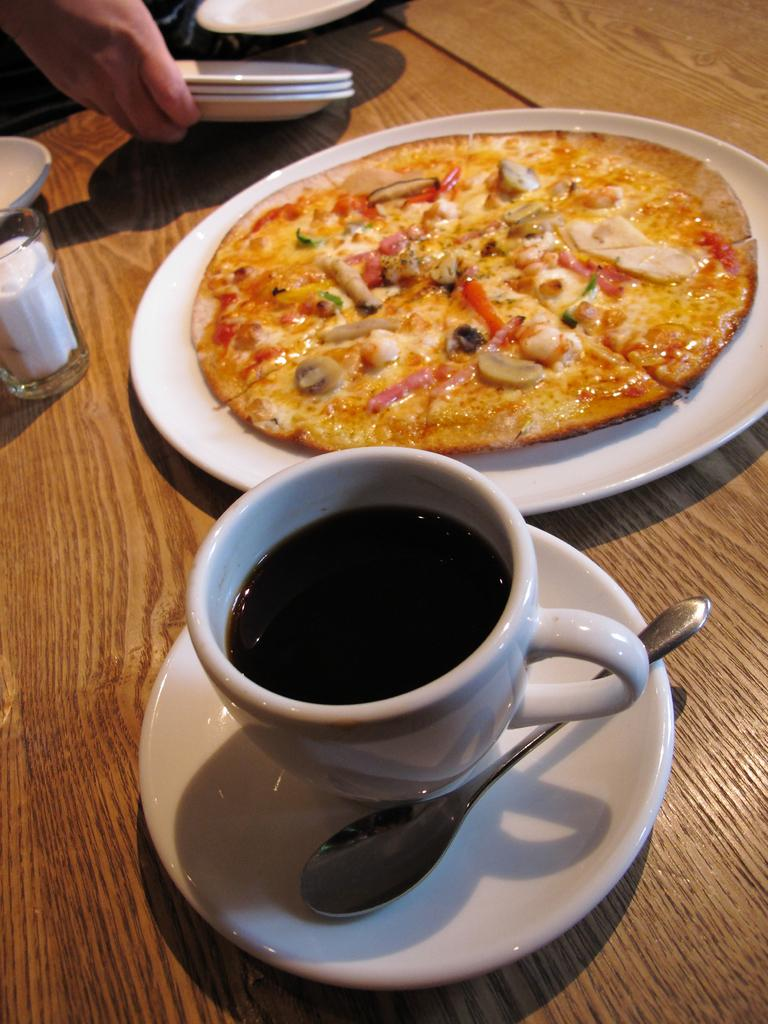What type of food is shown in the image? There is a pizza in the image. How is the pizza presented? The pizza is on a plate. What other items can be seen near the pizza? There is a cup beside the plate, and a spoon in a saucer beside the plate as well. What else is on the table in the image? There is a glass on the table. What type of competition is taking place in the image? There is no competition present in the image; it features a pizza on a plate with other tableware. Can you see a donkey in the image? No, there is no donkey present in the image. 